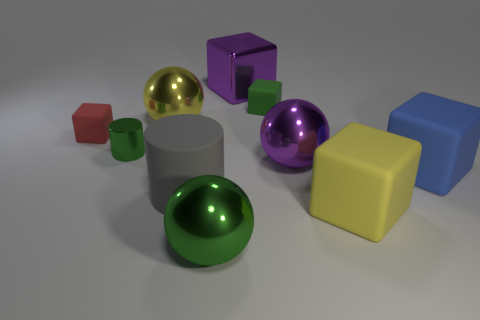There is a small rubber object that is the same color as the small metal cylinder; what is its shape?
Make the answer very short. Cube. There is a big sphere right of the big purple shiny cube; are there any purple shiny objects that are to the left of it?
Ensure brevity in your answer.  Yes. Is there a large green rubber cylinder?
Provide a short and direct response. No. How many other yellow cylinders are the same size as the metallic cylinder?
Offer a terse response. 0. How many tiny green things are on the left side of the big green sphere and right of the tiny metal object?
Your response must be concise. 0. There is a cube that is in front of the blue rubber object; is it the same size as the big green thing?
Your answer should be very brief. Yes. Is there a large cylinder of the same color as the tiny cylinder?
Provide a succinct answer. No. The green cube that is the same material as the big cylinder is what size?
Provide a succinct answer. Small. Is the number of purple blocks that are right of the yellow cube greater than the number of purple metallic spheres behind the yellow sphere?
Offer a very short reply. No. What number of other objects are the same material as the big gray object?
Your answer should be very brief. 4. 